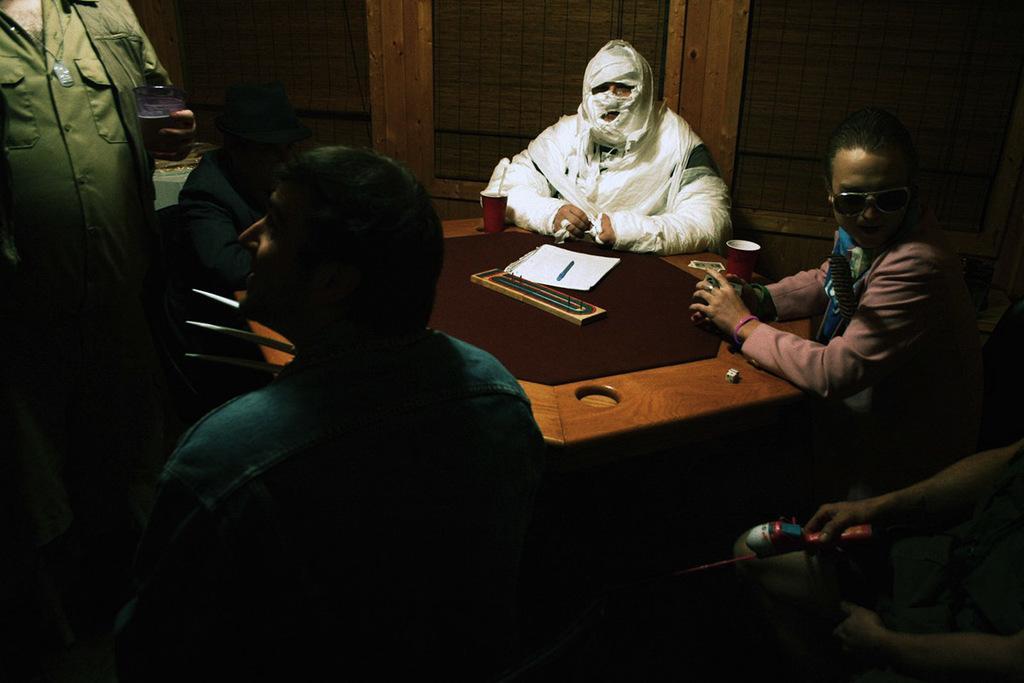Could you give a brief overview of what you see in this image? In this image there are group of people sitting around the table in which one of them is having bandage in the whole body, also there is a paper, pen and other things on table. 